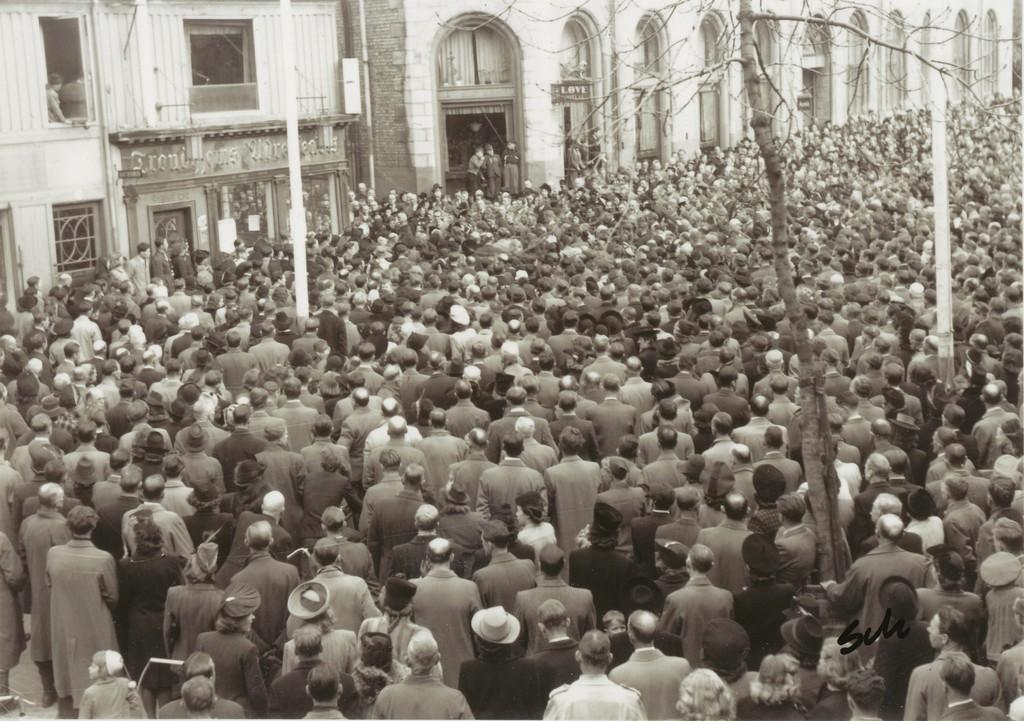How many people are in the image? There is a group of people standing in the image. What can be seen in the background of the image? There are poles and buildings in the background of the image. What is the color scheme of the image? The image is in black and white. Are there any cribs visible in the image? There are no cribs present in the image. How many sisters are standing together in the image? The image does not specify the relationship between the people, so we cannot determine the number of sisters. 